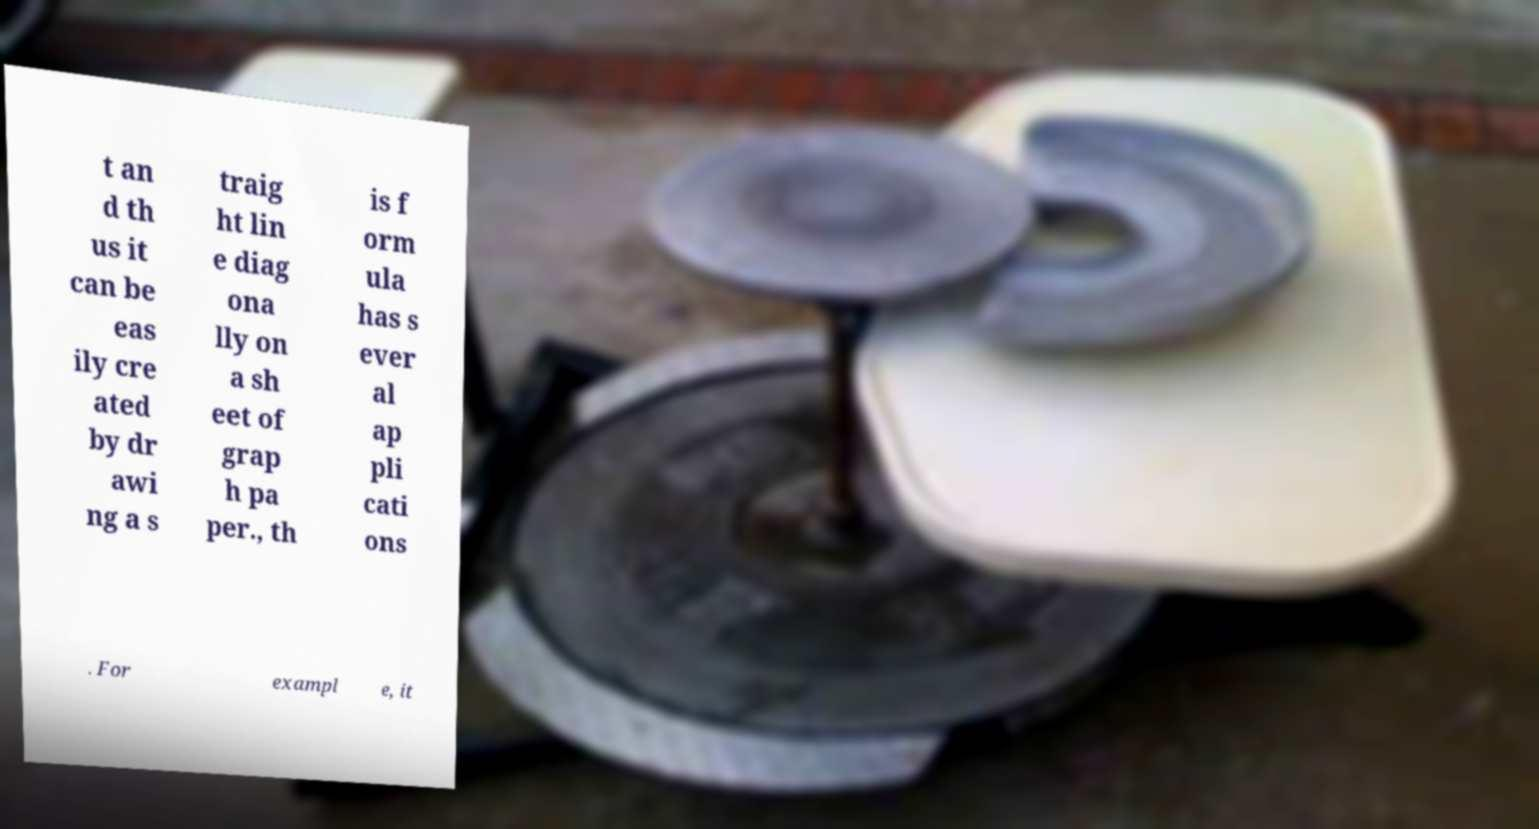Could you assist in decoding the text presented in this image and type it out clearly? t an d th us it can be eas ily cre ated by dr awi ng a s traig ht lin e diag ona lly on a sh eet of grap h pa per., th is f orm ula has s ever al ap pli cati ons . For exampl e, it 